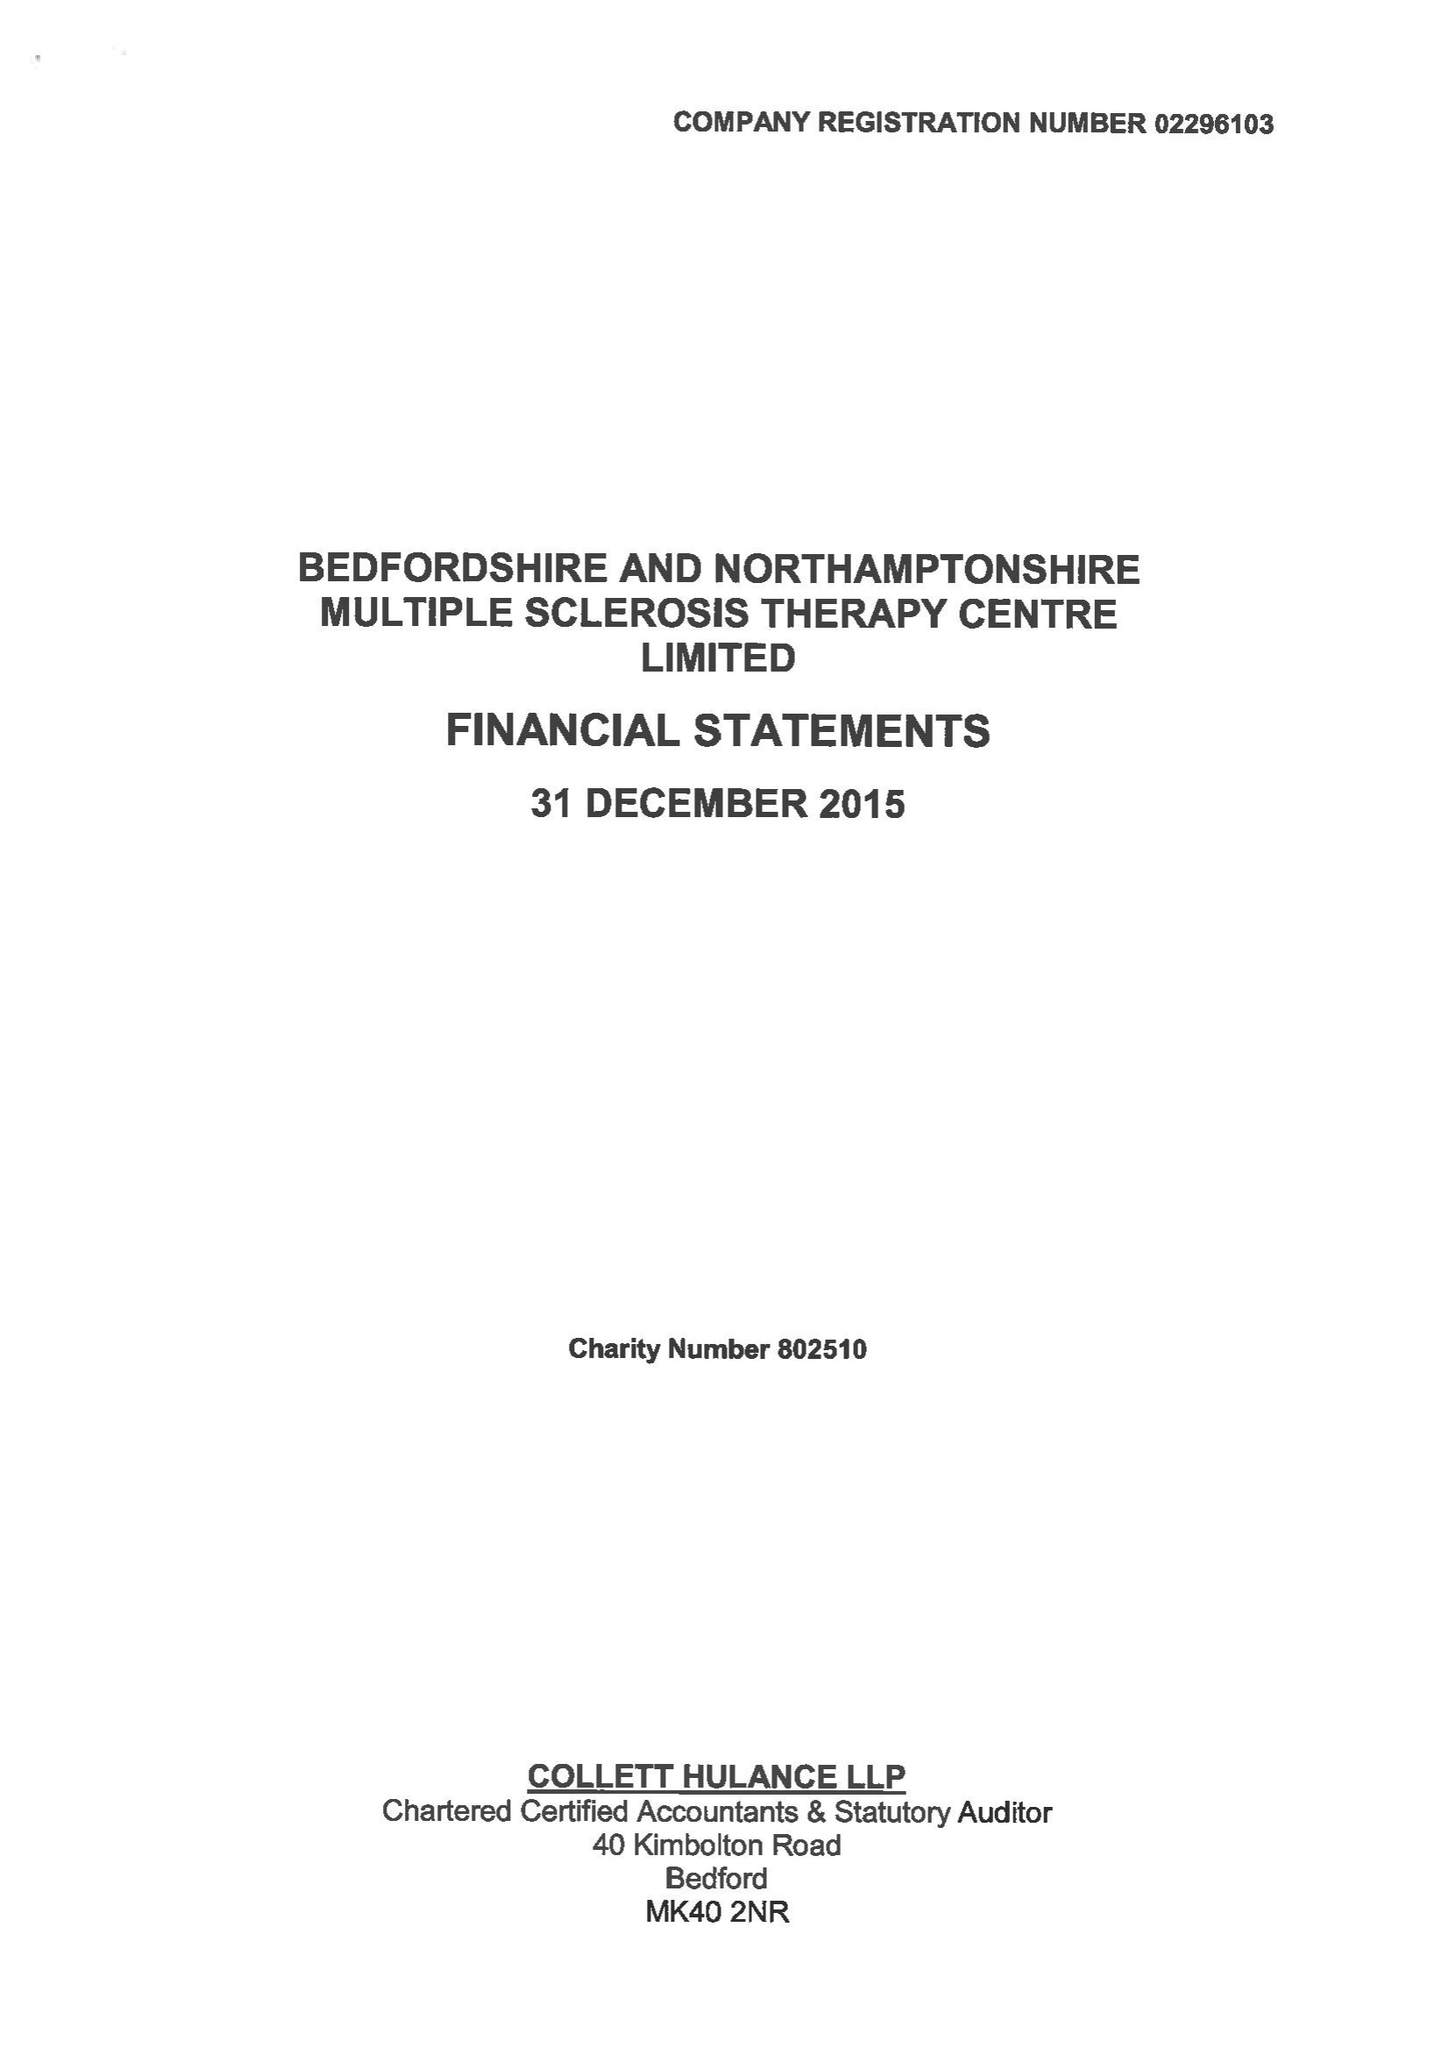What is the value for the address__postcode?
Answer the question using a single word or phrase. MK41 9RX 